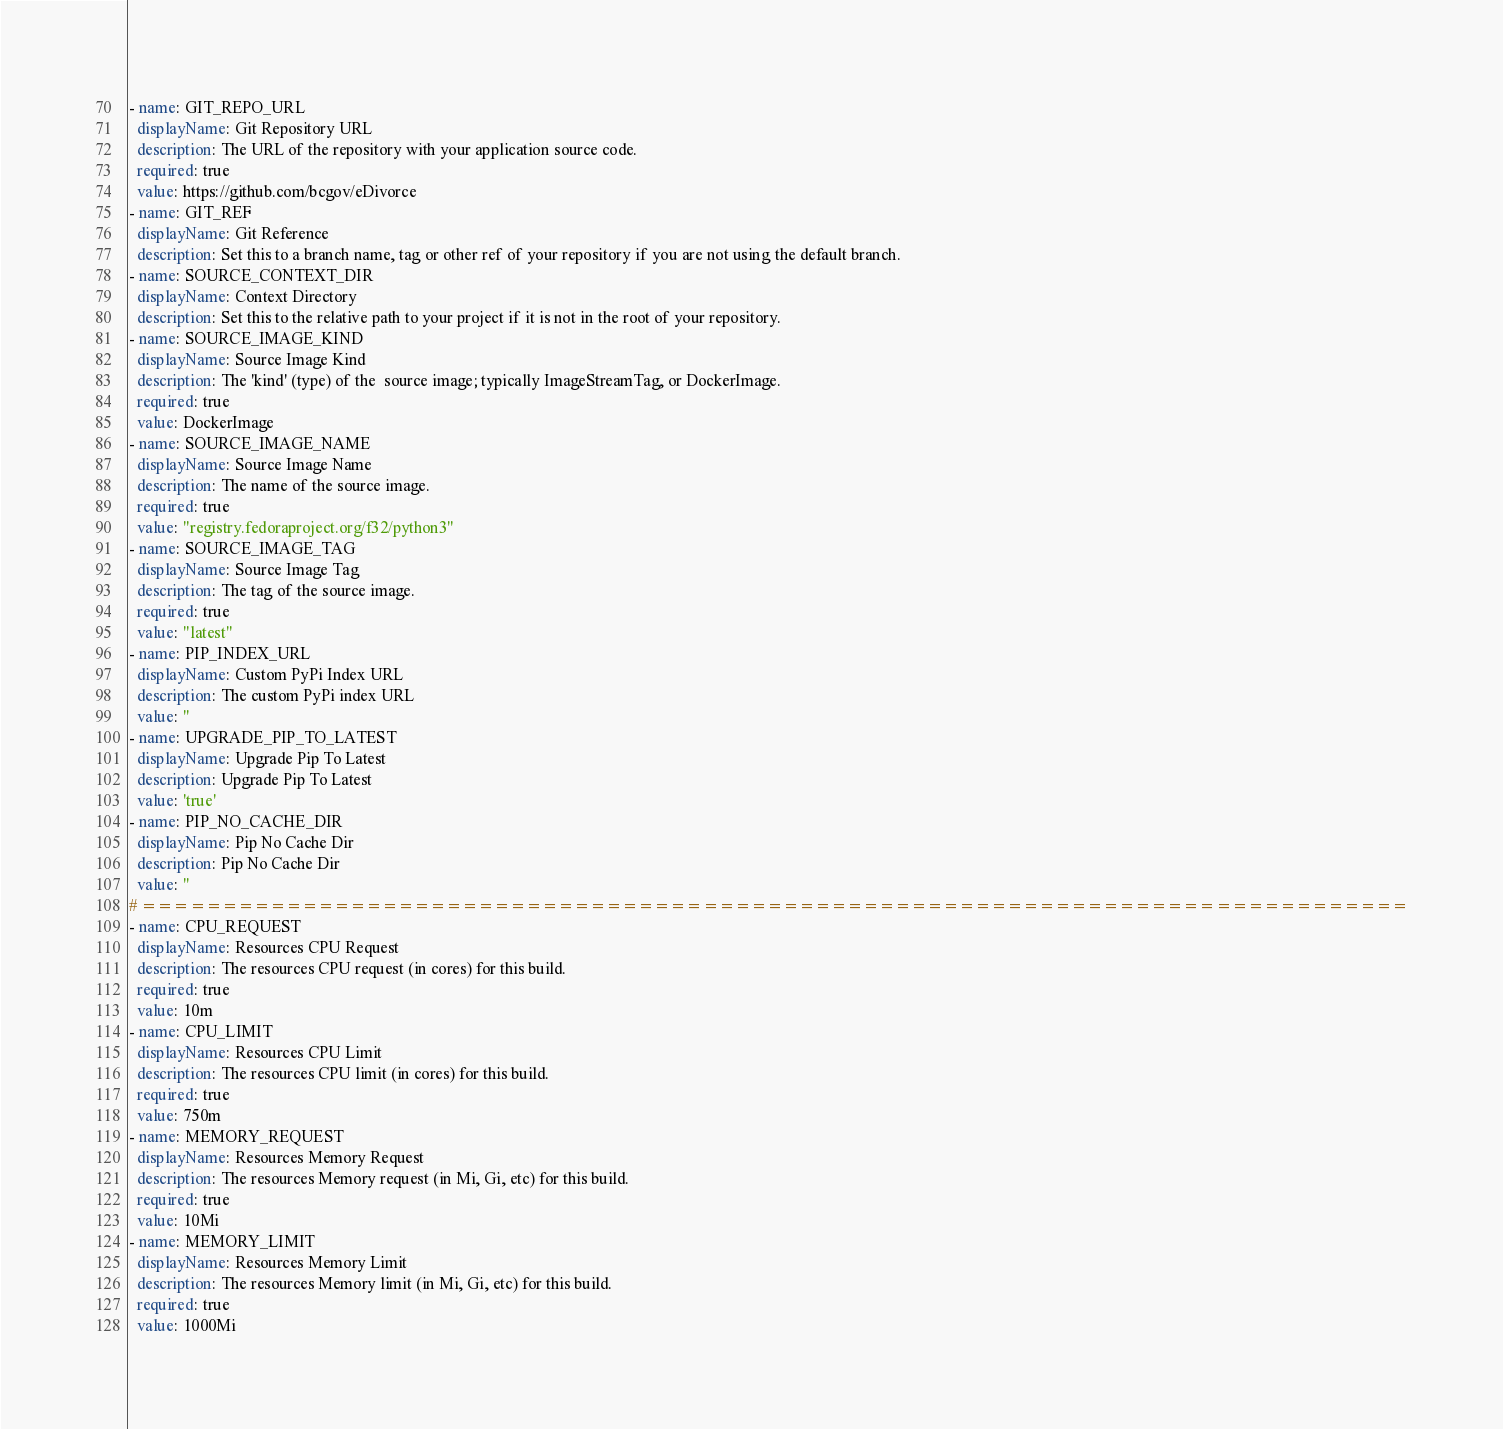<code> <loc_0><loc_0><loc_500><loc_500><_YAML_>- name: GIT_REPO_URL
  displayName: Git Repository URL
  description: The URL of the repository with your application source code.
  required: true
  value: https://github.com/bcgov/eDivorce
- name: GIT_REF
  displayName: Git Reference
  description: Set this to a branch name, tag or other ref of your repository if you are not using the default branch.
- name: SOURCE_CONTEXT_DIR
  displayName: Context Directory
  description: Set this to the relative path to your project if it is not in the root of your repository.
- name: SOURCE_IMAGE_KIND
  displayName: Source Image Kind
  description: The 'kind' (type) of the  source image; typically ImageStreamTag, or DockerImage.
  required: true
  value: DockerImage
- name: SOURCE_IMAGE_NAME
  displayName: Source Image Name
  description: The name of the source image.
  required: true
  value: "registry.fedoraproject.org/f32/python3"
- name: SOURCE_IMAGE_TAG
  displayName: Source Image Tag
  description: The tag of the source image.
  required: true
  value: "latest"
- name: PIP_INDEX_URL
  displayName: Custom PyPi Index URL
  description: The custom PyPi index URL
  value: ''
- name: UPGRADE_PIP_TO_LATEST
  displayName: Upgrade Pip To Latest
  description: Upgrade Pip To Latest
  value: 'true'
- name: PIP_NO_CACHE_DIR
  displayName: Pip No Cache Dir
  description: Pip No Cache Dir
  value: ''
# ===============================================================================
- name: CPU_REQUEST
  displayName: Resources CPU Request
  description: The resources CPU request (in cores) for this build.
  required: true
  value: 10m
- name: CPU_LIMIT
  displayName: Resources CPU Limit
  description: The resources CPU limit (in cores) for this build.
  required: true
  value: 750m
- name: MEMORY_REQUEST
  displayName: Resources Memory Request
  description: The resources Memory request (in Mi, Gi, etc) for this build.
  required: true
  value: 10Mi
- name: MEMORY_LIMIT
  displayName: Resources Memory Limit
  description: The resources Memory limit (in Mi, Gi, etc) for this build.
  required: true
  value: 1000Mi</code> 